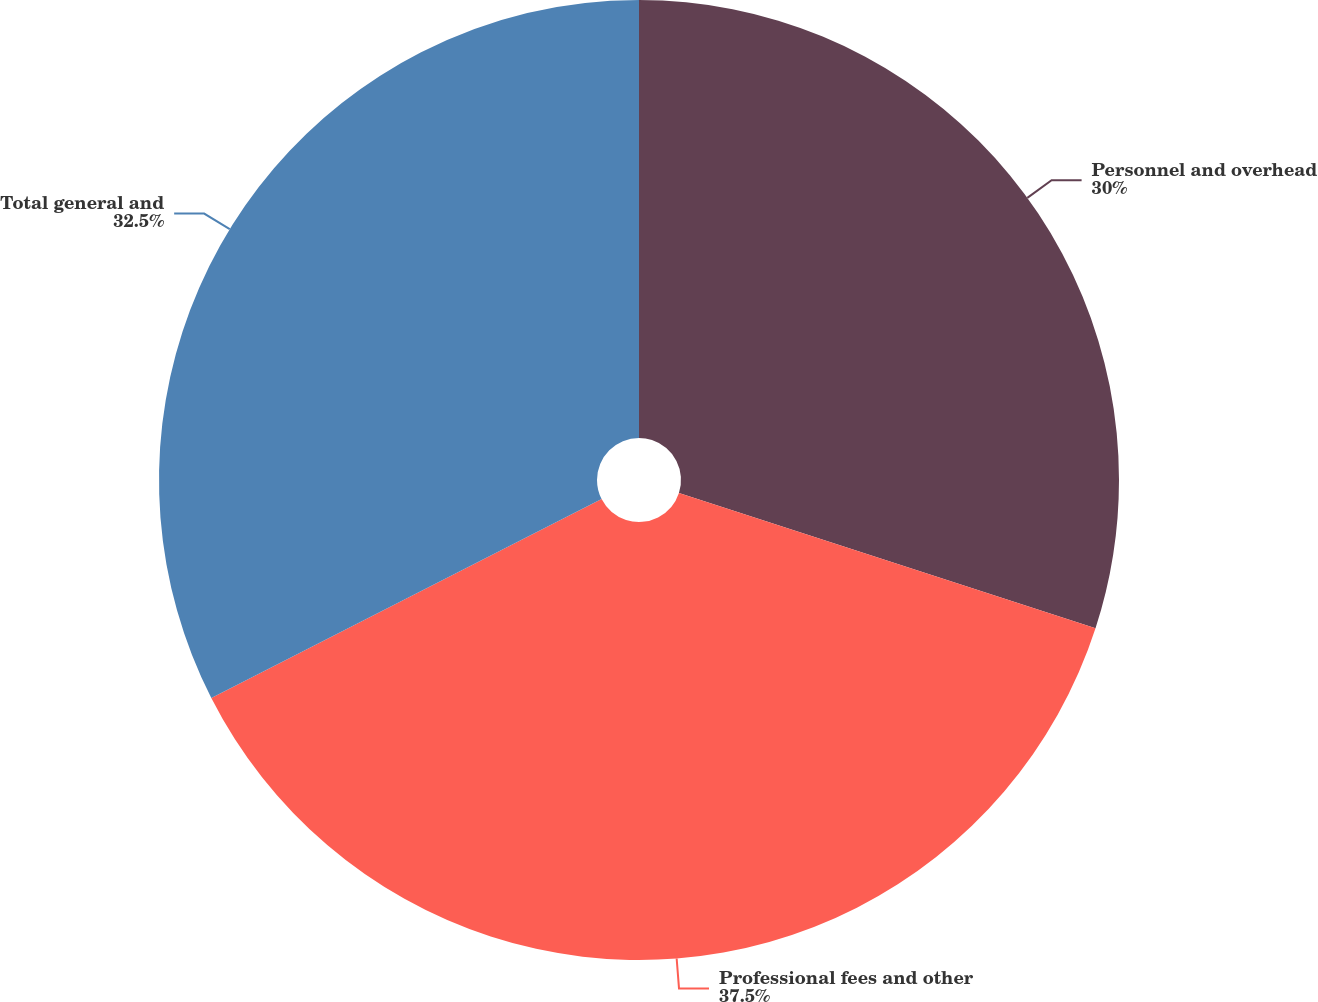Convert chart to OTSL. <chart><loc_0><loc_0><loc_500><loc_500><pie_chart><fcel>Personnel and overhead<fcel>Professional fees and other<fcel>Total general and<nl><fcel>30.0%<fcel>37.5%<fcel>32.5%<nl></chart> 